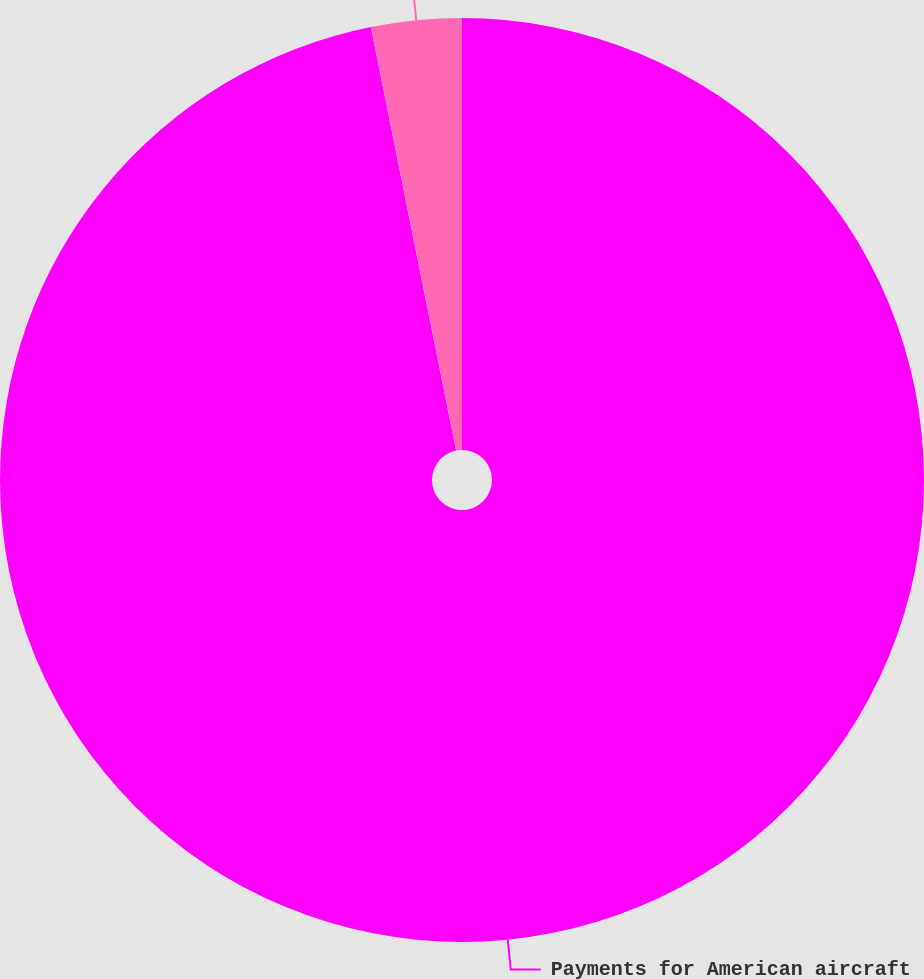<chart> <loc_0><loc_0><loc_500><loc_500><pie_chart><fcel>Payments for American aircraft<fcel>Payments for US Airways<nl><fcel>96.84%<fcel>3.16%<nl></chart> 